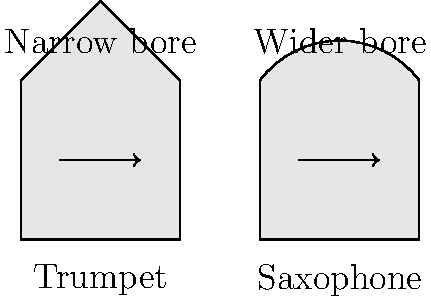Based on the cross-sectional diagrams of trumpet and saxophone mouthpieces shown above, how would the difference in bore shape likely affect the airflow and consequently the sound production in these instruments? To answer this question, let's analyze the diagrams step-by-step:

1. Trumpet mouthpiece:
   - Has a narrower, more conical shape
   - The bore (internal diameter) is smaller and more uniform

2. Saxophone mouthpiece:
   - Has a wider, more curved shape
   - The bore is larger and less uniform

3. Airflow characteristics:
   - In the trumpet, the narrow bore creates higher air pressure and velocity
   - In the saxophone, the wider bore allows for lower air pressure and velocity

4. Effect on sound production:
   - Higher air pressure and velocity in the trumpet leads to:
     a) Brighter, more piercing tone
     b) Greater ease in producing higher harmonics
   - Lower air pressure and velocity in the saxophone results in:
     a) Warmer, mellower tone
     b) Easier production of lower notes

5. Resistance:
   - The trumpet's narrower bore offers more resistance to airflow
   - The saxophone's wider bore provides less resistance to airflow

6. Player's perspective:
   - Trumpet players need to use more focused, high-pressure air stream
   - Saxophone players can use a more relaxed, broader air stream

The difference in bore shape between the trumpet and saxophone mouthpieces significantly affects the airflow patterns, which in turn influences the timbre, range, and playing characteristics of each instrument.
Answer: The trumpet's narrower bore creates higher air pressure and velocity, producing a brighter tone with easier high notes, while the saxophone's wider bore allows lower pressure and velocity, resulting in a warmer tone with easier low notes. 